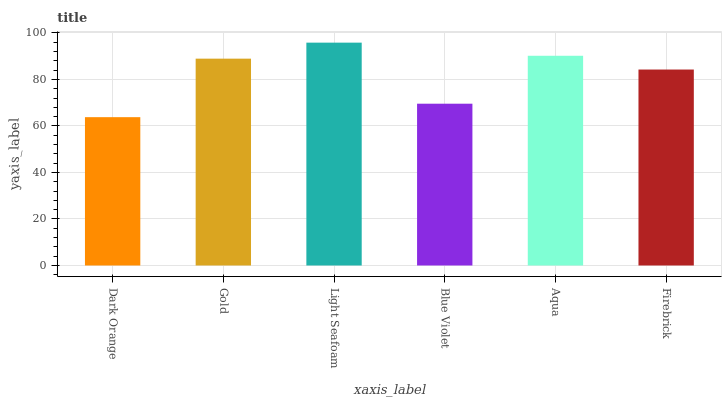Is Dark Orange the minimum?
Answer yes or no. Yes. Is Light Seafoam the maximum?
Answer yes or no. Yes. Is Gold the minimum?
Answer yes or no. No. Is Gold the maximum?
Answer yes or no. No. Is Gold greater than Dark Orange?
Answer yes or no. Yes. Is Dark Orange less than Gold?
Answer yes or no. Yes. Is Dark Orange greater than Gold?
Answer yes or no. No. Is Gold less than Dark Orange?
Answer yes or no. No. Is Gold the high median?
Answer yes or no. Yes. Is Firebrick the low median?
Answer yes or no. Yes. Is Light Seafoam the high median?
Answer yes or no. No. Is Blue Violet the low median?
Answer yes or no. No. 